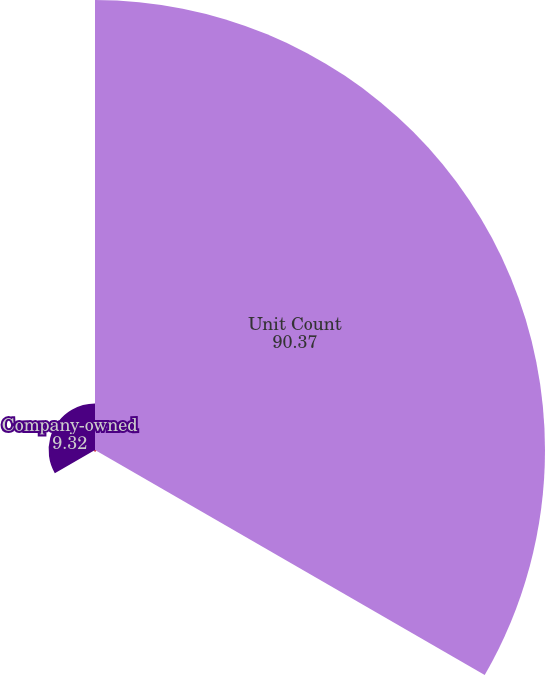<chart> <loc_0><loc_0><loc_500><loc_500><pie_chart><fcel>Unit Count<fcel>Franchise<fcel>Company-owned<nl><fcel>90.37%<fcel>0.31%<fcel>9.32%<nl></chart> 